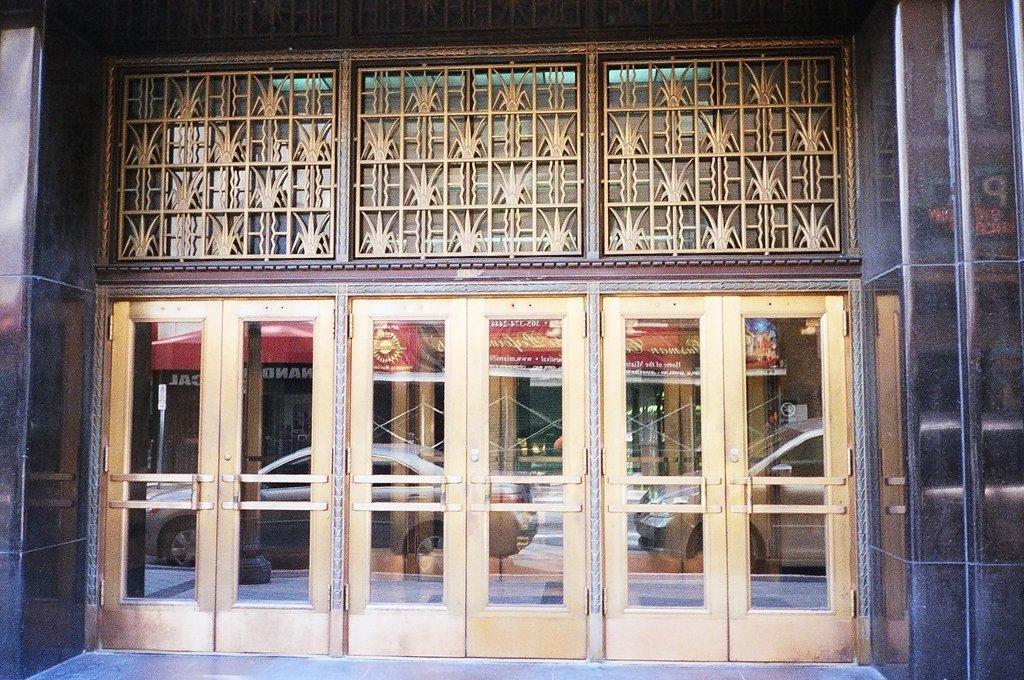Can you describe this image briefly? In this image I can see the building and there are the glass doors to it. Through the glass I can see the vehicles and other building. 